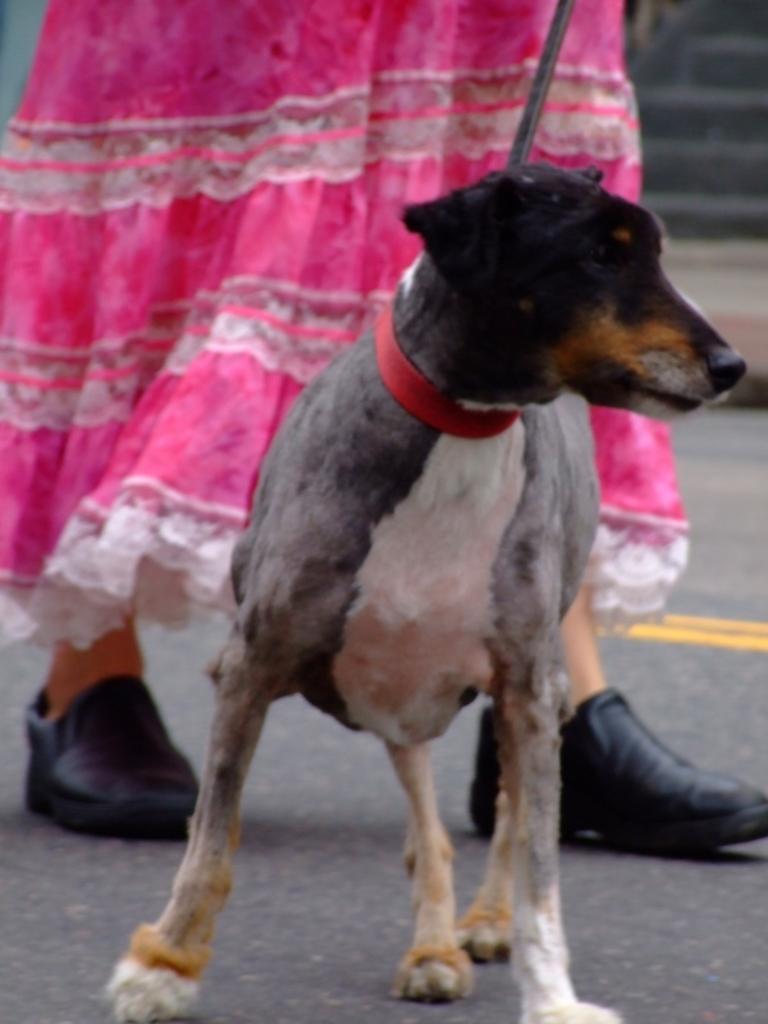Please provide a concise description of this image. In the image there is a dog stood on road and behind it there is a woman walking. 